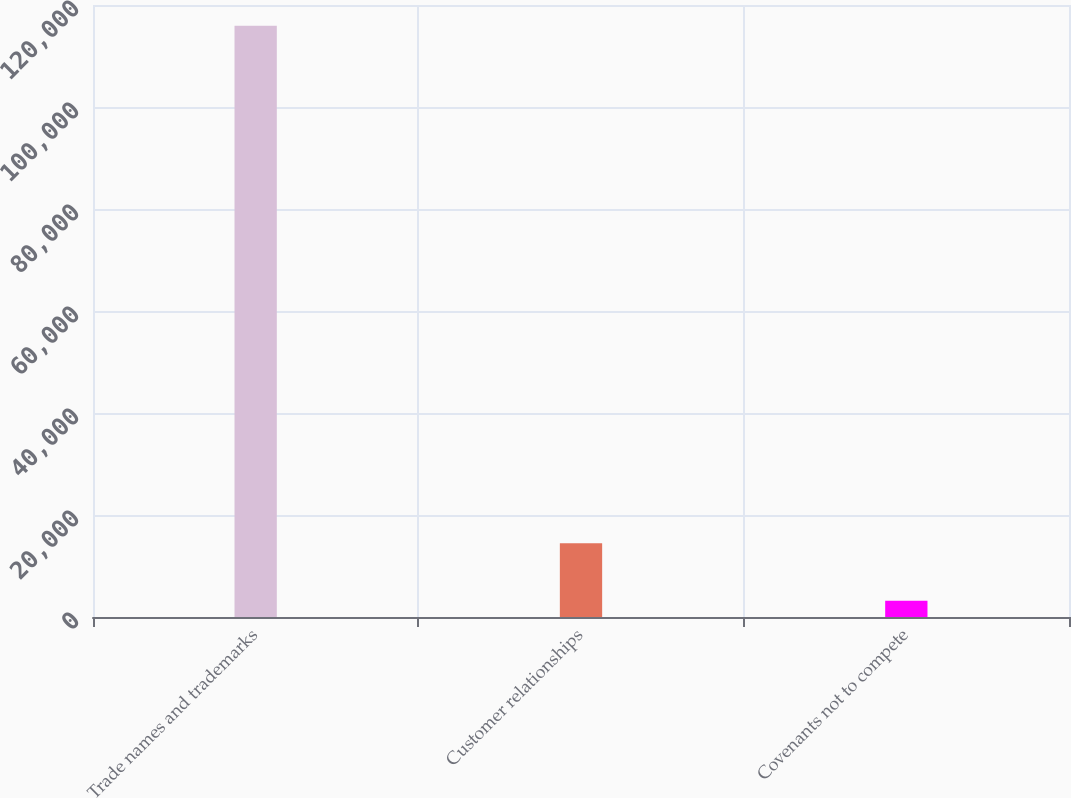<chart> <loc_0><loc_0><loc_500><loc_500><bar_chart><fcel>Trade names and trademarks<fcel>Customer relationships<fcel>Covenants not to compete<nl><fcel>115954<fcel>14470<fcel>3194<nl></chart> 